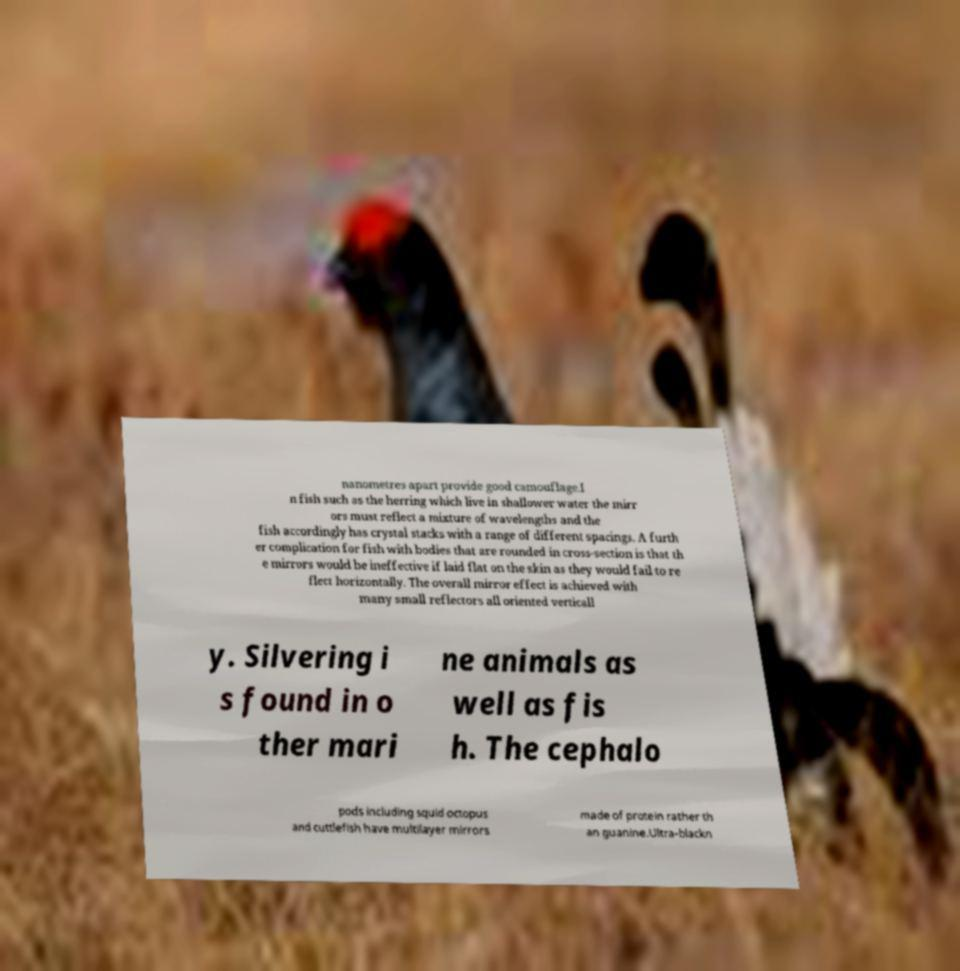For documentation purposes, I need the text within this image transcribed. Could you provide that? nanometres apart provide good camouflage.I n fish such as the herring which live in shallower water the mirr ors must reflect a mixture of wavelengths and the fish accordingly has crystal stacks with a range of different spacings. A furth er complication for fish with bodies that are rounded in cross-section is that th e mirrors would be ineffective if laid flat on the skin as they would fail to re flect horizontally. The overall mirror effect is achieved with many small reflectors all oriented verticall y. Silvering i s found in o ther mari ne animals as well as fis h. The cephalo pods including squid octopus and cuttlefish have multilayer mirrors made of protein rather th an guanine.Ultra-blackn 